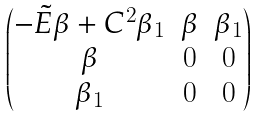Convert formula to latex. <formula><loc_0><loc_0><loc_500><loc_500>\begin{pmatrix} - \tilde { E } \beta + C ^ { 2 } \beta _ { 1 } & \beta & \beta _ { 1 } \\ \beta & 0 & 0 \\ \beta _ { 1 } & 0 & 0 \end{pmatrix}</formula> 